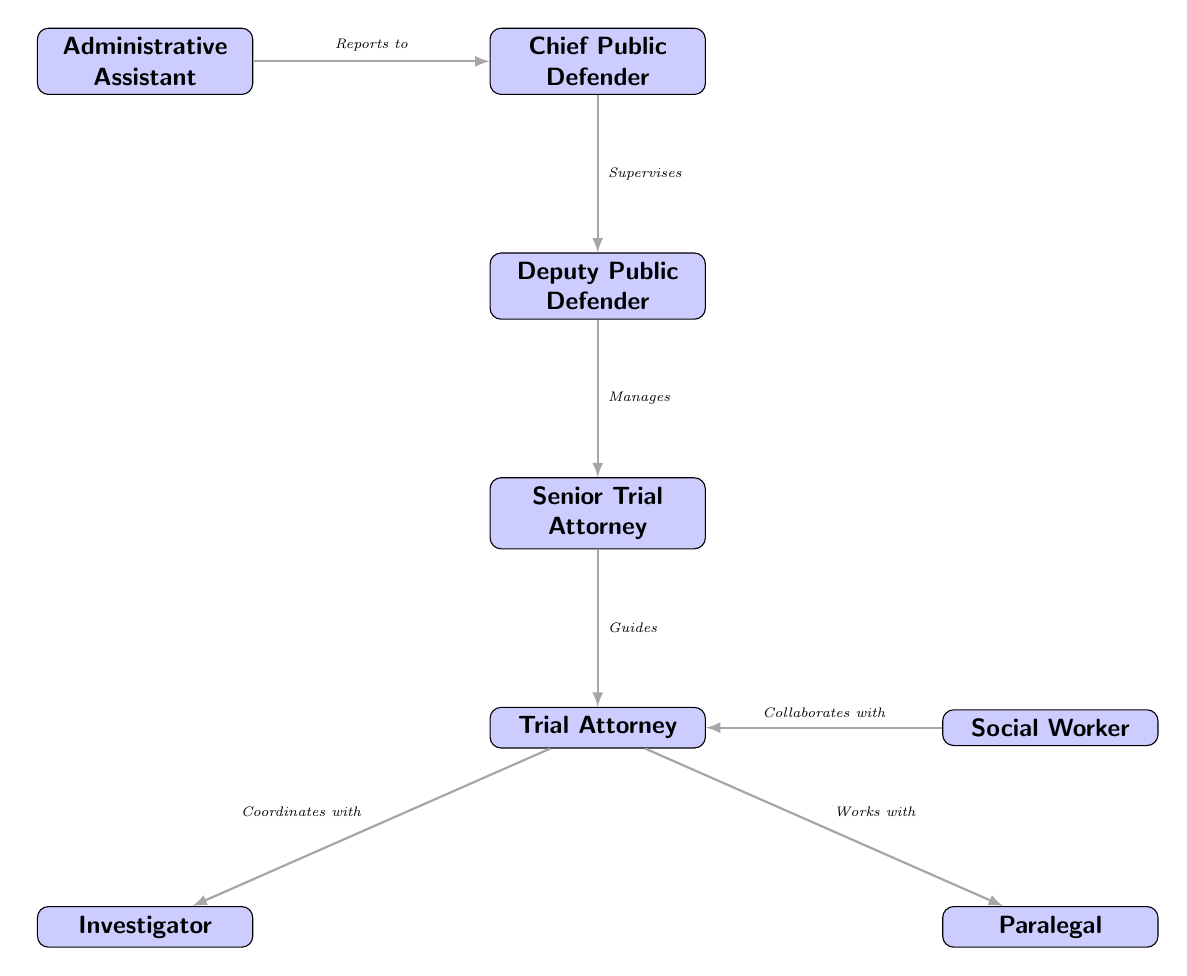What is the highest position in the diagram? The highest position in the diagram is indicated by the topmost node. In this case, the topmost node is the Chief Public Defender, making it the highest position.
Answer: Chief Public Defender How many nodes are in the diagram? To determine the number of nodes, we need to count each unique position represented in the diagram. There are one Chief Public Defender, one Deputy Public Defender, one Senior Trial Attorney, one Trial Attorney, one Investigator, one Paralegal, one Administrative Assistant, and one Social Worker, totaling eight nodes.
Answer: 8 What is the role directly below the Deputy Public Defender? The role directly below the Deputy Public Defender is found by looking at the connection downwards from the Deputy Public Defender node. The next node below it is the Senior Trial Attorney.
Answer: Senior Trial Attorney Who does the Trial Attorney coordinate with? The Trial Attorney's coordination is indicated by the connection to another role. The diagram shows that the Trial Attorney coordinates with the Investigator, which is depicted by an arrow pointing towards the Investigator node.
Answer: Investigator What is the relationship between the Chief Public Defender and the Administrative Assistant? The relationship is established by looking at the arrows in the diagram. The diagram illustrates that the Administrative Assistant reports to the Chief Public Defender, as denoted by the directional arrow connecting the two.
Answer: Reports to Which roles does the Trial Attorney work with? To answer this, we analyze the connections leading from the Trial Attorney node to see with whom they have relationships. The diagram shows that the Trial Attorney works with both the Investigator and the Paralegal.
Answer: Investigator, Paralegal What is the role immediately above the Trial Attorney? We find the role immediately above the Trial Attorney by following the direct upward connection in the diagram. The role located one step above the Trial Attorney is the Senior Trial Attorney.
Answer: Senior Trial Attorney How does the Deputy Public Defender relate to the Senior Trial Attorney? We look for the connection between the Deputy Public Defender and the Senior Trial Attorney. The diagram shows that the Deputy Public Defender manages the Senior Trial Attorney, indicating a supervisory relationship.
Answer: Manages Which role collaborates with the Trial Attorney? By examining the social relationships depicted in the diagram, we see that the role that collaborates with the Trial Attorney is the Social Worker, as indicated by the connection leading to the Trial Attorney from the Social Worker node.
Answer: Social Worker 